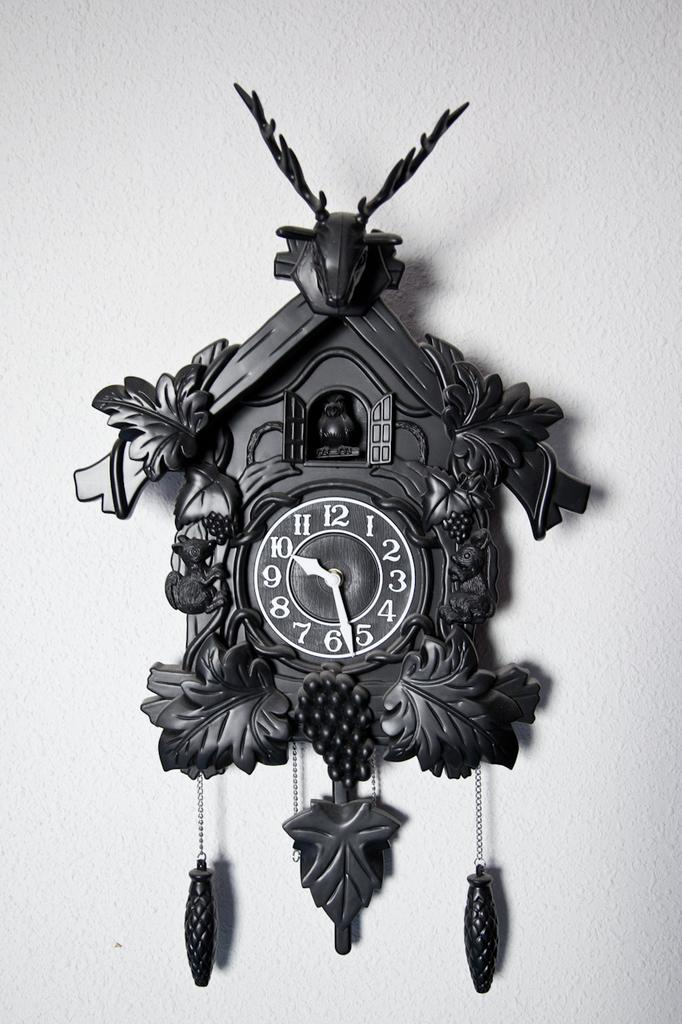What object can be seen in the picture? There is a clock in the picture. Where is the clock located? The clock is placed on a wall. What is unique about the design of the clock? The clock is shaped like a hut. What type of spring can be seen in the picture? There is no spring present in the picture; it features a clock shaped like a hut on a wall. 